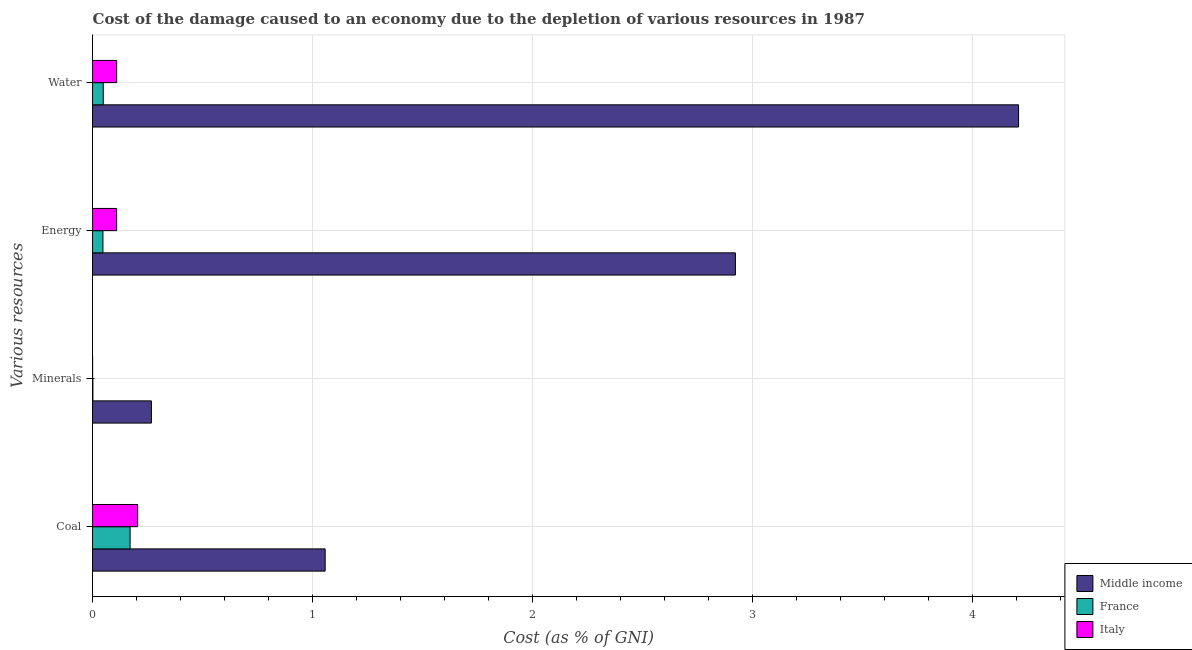How many different coloured bars are there?
Offer a terse response. 3. How many groups of bars are there?
Your response must be concise. 4. How many bars are there on the 3rd tick from the top?
Provide a short and direct response. 3. What is the label of the 2nd group of bars from the top?
Your response must be concise. Energy. What is the cost of damage due to depletion of water in Italy?
Give a very brief answer. 0.11. Across all countries, what is the maximum cost of damage due to depletion of energy?
Provide a short and direct response. 2.92. Across all countries, what is the minimum cost of damage due to depletion of minerals?
Make the answer very short. 5.38016343231856e-5. In which country was the cost of damage due to depletion of energy maximum?
Your response must be concise. Middle income. What is the total cost of damage due to depletion of energy in the graph?
Offer a very short reply. 3.08. What is the difference between the cost of damage due to depletion of coal in Middle income and that in Italy?
Ensure brevity in your answer.  0.85. What is the difference between the cost of damage due to depletion of minerals in France and the cost of damage due to depletion of coal in Italy?
Your answer should be very brief. -0.2. What is the average cost of damage due to depletion of coal per country?
Provide a short and direct response. 0.48. What is the difference between the cost of damage due to depletion of water and cost of damage due to depletion of energy in Middle income?
Offer a terse response. 1.29. What is the ratio of the cost of damage due to depletion of water in Italy to that in Middle income?
Your answer should be very brief. 0.03. Is the cost of damage due to depletion of minerals in France less than that in Middle income?
Your answer should be compact. Yes. What is the difference between the highest and the second highest cost of damage due to depletion of energy?
Offer a terse response. 2.81. What is the difference between the highest and the lowest cost of damage due to depletion of water?
Your response must be concise. 4.16. Is the sum of the cost of damage due to depletion of coal in France and Middle income greater than the maximum cost of damage due to depletion of minerals across all countries?
Your answer should be very brief. Yes. Is it the case that in every country, the sum of the cost of damage due to depletion of water and cost of damage due to depletion of coal is greater than the sum of cost of damage due to depletion of energy and cost of damage due to depletion of minerals?
Make the answer very short. No. Is it the case that in every country, the sum of the cost of damage due to depletion of coal and cost of damage due to depletion of minerals is greater than the cost of damage due to depletion of energy?
Your answer should be very brief. No. How many countries are there in the graph?
Make the answer very short. 3. Does the graph contain any zero values?
Offer a terse response. No. How many legend labels are there?
Your answer should be compact. 3. How are the legend labels stacked?
Provide a succinct answer. Vertical. What is the title of the graph?
Offer a very short reply. Cost of the damage caused to an economy due to the depletion of various resources in 1987 . Does "Paraguay" appear as one of the legend labels in the graph?
Provide a short and direct response. No. What is the label or title of the X-axis?
Provide a short and direct response. Cost (as % of GNI). What is the label or title of the Y-axis?
Give a very brief answer. Various resources. What is the Cost (as % of GNI) of Middle income in Coal?
Provide a succinct answer. 1.06. What is the Cost (as % of GNI) of France in Coal?
Ensure brevity in your answer.  0.17. What is the Cost (as % of GNI) in Italy in Coal?
Give a very brief answer. 0.21. What is the Cost (as % of GNI) of Middle income in Minerals?
Your response must be concise. 0.27. What is the Cost (as % of GNI) in France in Minerals?
Offer a terse response. 0. What is the Cost (as % of GNI) in Italy in Minerals?
Provide a succinct answer. 5.38016343231856e-5. What is the Cost (as % of GNI) of Middle income in Energy?
Offer a terse response. 2.92. What is the Cost (as % of GNI) in France in Energy?
Provide a succinct answer. 0.05. What is the Cost (as % of GNI) in Italy in Energy?
Provide a succinct answer. 0.11. What is the Cost (as % of GNI) in Middle income in Water?
Provide a succinct answer. 4.21. What is the Cost (as % of GNI) in France in Water?
Your response must be concise. 0.05. What is the Cost (as % of GNI) in Italy in Water?
Provide a short and direct response. 0.11. Across all Various resources, what is the maximum Cost (as % of GNI) in Middle income?
Your answer should be compact. 4.21. Across all Various resources, what is the maximum Cost (as % of GNI) of France?
Your response must be concise. 0.17. Across all Various resources, what is the maximum Cost (as % of GNI) in Italy?
Your answer should be compact. 0.21. Across all Various resources, what is the minimum Cost (as % of GNI) of Middle income?
Ensure brevity in your answer.  0.27. Across all Various resources, what is the minimum Cost (as % of GNI) of France?
Your answer should be very brief. 0. Across all Various resources, what is the minimum Cost (as % of GNI) in Italy?
Ensure brevity in your answer.  5.38016343231856e-5. What is the total Cost (as % of GNI) in Middle income in the graph?
Give a very brief answer. 8.46. What is the total Cost (as % of GNI) in France in the graph?
Your answer should be very brief. 0.27. What is the total Cost (as % of GNI) of Italy in the graph?
Ensure brevity in your answer.  0.42. What is the difference between the Cost (as % of GNI) of Middle income in Coal and that in Minerals?
Ensure brevity in your answer.  0.79. What is the difference between the Cost (as % of GNI) in France in Coal and that in Minerals?
Your answer should be very brief. 0.17. What is the difference between the Cost (as % of GNI) in Italy in Coal and that in Minerals?
Your response must be concise. 0.2. What is the difference between the Cost (as % of GNI) in Middle income in Coal and that in Energy?
Your response must be concise. -1.86. What is the difference between the Cost (as % of GNI) of France in Coal and that in Energy?
Provide a succinct answer. 0.12. What is the difference between the Cost (as % of GNI) of Italy in Coal and that in Energy?
Make the answer very short. 0.1. What is the difference between the Cost (as % of GNI) of Middle income in Coal and that in Water?
Ensure brevity in your answer.  -3.15. What is the difference between the Cost (as % of GNI) of France in Coal and that in Water?
Ensure brevity in your answer.  0.12. What is the difference between the Cost (as % of GNI) in Italy in Coal and that in Water?
Offer a terse response. 0.1. What is the difference between the Cost (as % of GNI) in Middle income in Minerals and that in Energy?
Provide a short and direct response. -2.65. What is the difference between the Cost (as % of GNI) in France in Minerals and that in Energy?
Your response must be concise. -0.05. What is the difference between the Cost (as % of GNI) in Italy in Minerals and that in Energy?
Offer a very short reply. -0.11. What is the difference between the Cost (as % of GNI) of Middle income in Minerals and that in Water?
Provide a short and direct response. -3.94. What is the difference between the Cost (as % of GNI) in France in Minerals and that in Water?
Offer a terse response. -0.05. What is the difference between the Cost (as % of GNI) of Italy in Minerals and that in Water?
Offer a terse response. -0.11. What is the difference between the Cost (as % of GNI) in Middle income in Energy and that in Water?
Offer a very short reply. -1.29. What is the difference between the Cost (as % of GNI) in France in Energy and that in Water?
Give a very brief answer. -0. What is the difference between the Cost (as % of GNI) of Italy in Energy and that in Water?
Ensure brevity in your answer.  -0. What is the difference between the Cost (as % of GNI) of Middle income in Coal and the Cost (as % of GNI) of France in Minerals?
Ensure brevity in your answer.  1.06. What is the difference between the Cost (as % of GNI) of Middle income in Coal and the Cost (as % of GNI) of Italy in Minerals?
Provide a short and direct response. 1.06. What is the difference between the Cost (as % of GNI) of France in Coal and the Cost (as % of GNI) of Italy in Minerals?
Give a very brief answer. 0.17. What is the difference between the Cost (as % of GNI) in Middle income in Coal and the Cost (as % of GNI) in France in Energy?
Your response must be concise. 1.01. What is the difference between the Cost (as % of GNI) of Middle income in Coal and the Cost (as % of GNI) of Italy in Energy?
Ensure brevity in your answer.  0.95. What is the difference between the Cost (as % of GNI) of France in Coal and the Cost (as % of GNI) of Italy in Energy?
Provide a succinct answer. 0.06. What is the difference between the Cost (as % of GNI) of Middle income in Coal and the Cost (as % of GNI) of France in Water?
Your answer should be very brief. 1.01. What is the difference between the Cost (as % of GNI) in Middle income in Coal and the Cost (as % of GNI) in Italy in Water?
Give a very brief answer. 0.95. What is the difference between the Cost (as % of GNI) of France in Coal and the Cost (as % of GNI) of Italy in Water?
Your answer should be compact. 0.06. What is the difference between the Cost (as % of GNI) of Middle income in Minerals and the Cost (as % of GNI) of France in Energy?
Give a very brief answer. 0.22. What is the difference between the Cost (as % of GNI) of Middle income in Minerals and the Cost (as % of GNI) of Italy in Energy?
Make the answer very short. 0.16. What is the difference between the Cost (as % of GNI) in France in Minerals and the Cost (as % of GNI) in Italy in Energy?
Give a very brief answer. -0.11. What is the difference between the Cost (as % of GNI) of Middle income in Minerals and the Cost (as % of GNI) of France in Water?
Your response must be concise. 0.22. What is the difference between the Cost (as % of GNI) of Middle income in Minerals and the Cost (as % of GNI) of Italy in Water?
Offer a terse response. 0.16. What is the difference between the Cost (as % of GNI) of France in Minerals and the Cost (as % of GNI) of Italy in Water?
Keep it short and to the point. -0.11. What is the difference between the Cost (as % of GNI) in Middle income in Energy and the Cost (as % of GNI) in France in Water?
Provide a short and direct response. 2.87. What is the difference between the Cost (as % of GNI) in Middle income in Energy and the Cost (as % of GNI) in Italy in Water?
Keep it short and to the point. 2.81. What is the difference between the Cost (as % of GNI) of France in Energy and the Cost (as % of GNI) of Italy in Water?
Offer a terse response. -0.06. What is the average Cost (as % of GNI) of Middle income per Various resources?
Make the answer very short. 2.11. What is the average Cost (as % of GNI) of France per Various resources?
Offer a very short reply. 0.07. What is the average Cost (as % of GNI) in Italy per Various resources?
Give a very brief answer. 0.11. What is the difference between the Cost (as % of GNI) of Middle income and Cost (as % of GNI) of France in Coal?
Keep it short and to the point. 0.89. What is the difference between the Cost (as % of GNI) in Middle income and Cost (as % of GNI) in Italy in Coal?
Your response must be concise. 0.85. What is the difference between the Cost (as % of GNI) in France and Cost (as % of GNI) in Italy in Coal?
Provide a succinct answer. -0.03. What is the difference between the Cost (as % of GNI) of Middle income and Cost (as % of GNI) of France in Minerals?
Your answer should be compact. 0.27. What is the difference between the Cost (as % of GNI) in Middle income and Cost (as % of GNI) in Italy in Minerals?
Keep it short and to the point. 0.27. What is the difference between the Cost (as % of GNI) in France and Cost (as % of GNI) in Italy in Minerals?
Offer a terse response. 0. What is the difference between the Cost (as % of GNI) of Middle income and Cost (as % of GNI) of France in Energy?
Your response must be concise. 2.88. What is the difference between the Cost (as % of GNI) in Middle income and Cost (as % of GNI) in Italy in Energy?
Your answer should be compact. 2.81. What is the difference between the Cost (as % of GNI) of France and Cost (as % of GNI) of Italy in Energy?
Give a very brief answer. -0.06. What is the difference between the Cost (as % of GNI) of Middle income and Cost (as % of GNI) of France in Water?
Offer a very short reply. 4.16. What is the difference between the Cost (as % of GNI) of Middle income and Cost (as % of GNI) of Italy in Water?
Offer a very short reply. 4.1. What is the difference between the Cost (as % of GNI) in France and Cost (as % of GNI) in Italy in Water?
Provide a short and direct response. -0.06. What is the ratio of the Cost (as % of GNI) in Middle income in Coal to that in Minerals?
Your response must be concise. 3.95. What is the ratio of the Cost (as % of GNI) in France in Coal to that in Minerals?
Your answer should be compact. 119.72. What is the ratio of the Cost (as % of GNI) in Italy in Coal to that in Minerals?
Ensure brevity in your answer.  3810.3. What is the ratio of the Cost (as % of GNI) in Middle income in Coal to that in Energy?
Ensure brevity in your answer.  0.36. What is the ratio of the Cost (as % of GNI) in France in Coal to that in Energy?
Offer a very short reply. 3.62. What is the ratio of the Cost (as % of GNI) of Italy in Coal to that in Energy?
Provide a short and direct response. 1.87. What is the ratio of the Cost (as % of GNI) of Middle income in Coal to that in Water?
Your answer should be compact. 0.25. What is the ratio of the Cost (as % of GNI) in France in Coal to that in Water?
Your answer should be compact. 3.52. What is the ratio of the Cost (as % of GNI) in Italy in Coal to that in Water?
Offer a terse response. 1.87. What is the ratio of the Cost (as % of GNI) in Middle income in Minerals to that in Energy?
Offer a very short reply. 0.09. What is the ratio of the Cost (as % of GNI) in France in Minerals to that in Energy?
Make the answer very short. 0.03. What is the ratio of the Cost (as % of GNI) of Middle income in Minerals to that in Water?
Provide a short and direct response. 0.06. What is the ratio of the Cost (as % of GNI) of France in Minerals to that in Water?
Your answer should be compact. 0.03. What is the ratio of the Cost (as % of GNI) of Middle income in Energy to that in Water?
Make the answer very short. 0.69. What is the ratio of the Cost (as % of GNI) of France in Energy to that in Water?
Give a very brief answer. 0.97. What is the difference between the highest and the second highest Cost (as % of GNI) in Middle income?
Provide a succinct answer. 1.29. What is the difference between the highest and the second highest Cost (as % of GNI) in France?
Offer a terse response. 0.12. What is the difference between the highest and the second highest Cost (as % of GNI) of Italy?
Your response must be concise. 0.1. What is the difference between the highest and the lowest Cost (as % of GNI) of Middle income?
Provide a succinct answer. 3.94. What is the difference between the highest and the lowest Cost (as % of GNI) in France?
Offer a very short reply. 0.17. What is the difference between the highest and the lowest Cost (as % of GNI) of Italy?
Ensure brevity in your answer.  0.2. 